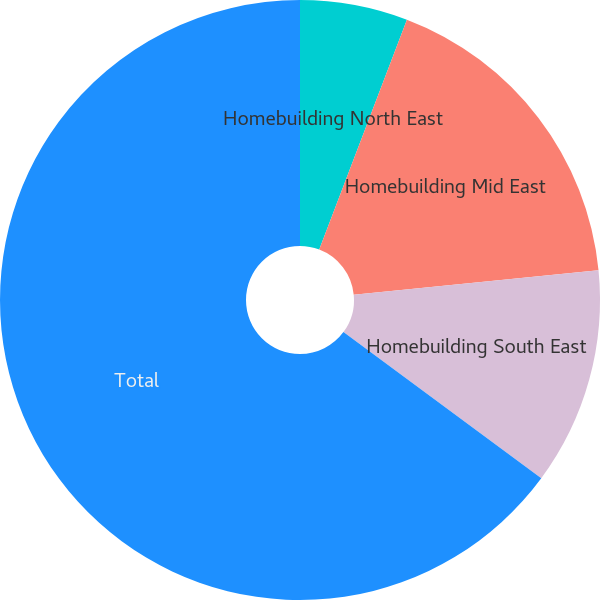Convert chart to OTSL. <chart><loc_0><loc_0><loc_500><loc_500><pie_chart><fcel>Homebuilding North East<fcel>Homebuilding Mid East<fcel>Homebuilding South East<fcel>Total<nl><fcel>5.8%<fcel>17.62%<fcel>11.71%<fcel>64.87%<nl></chart> 